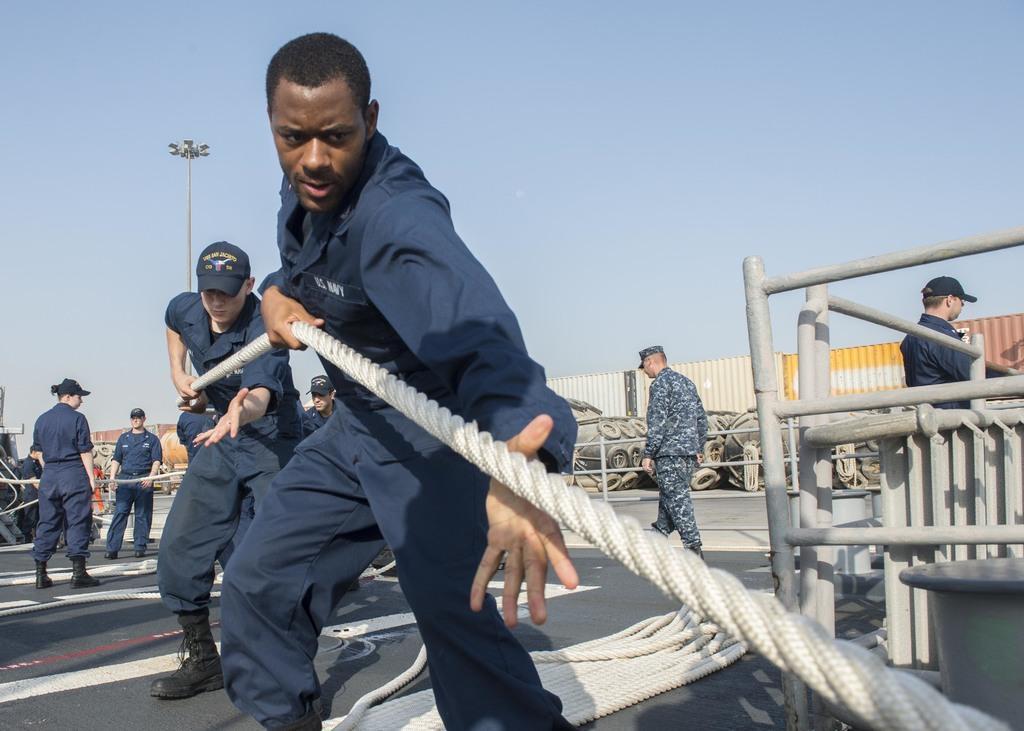Describe this image in one or two sentences. In the image there are few people pulling a rope and behind them there are many containers and some objects. 